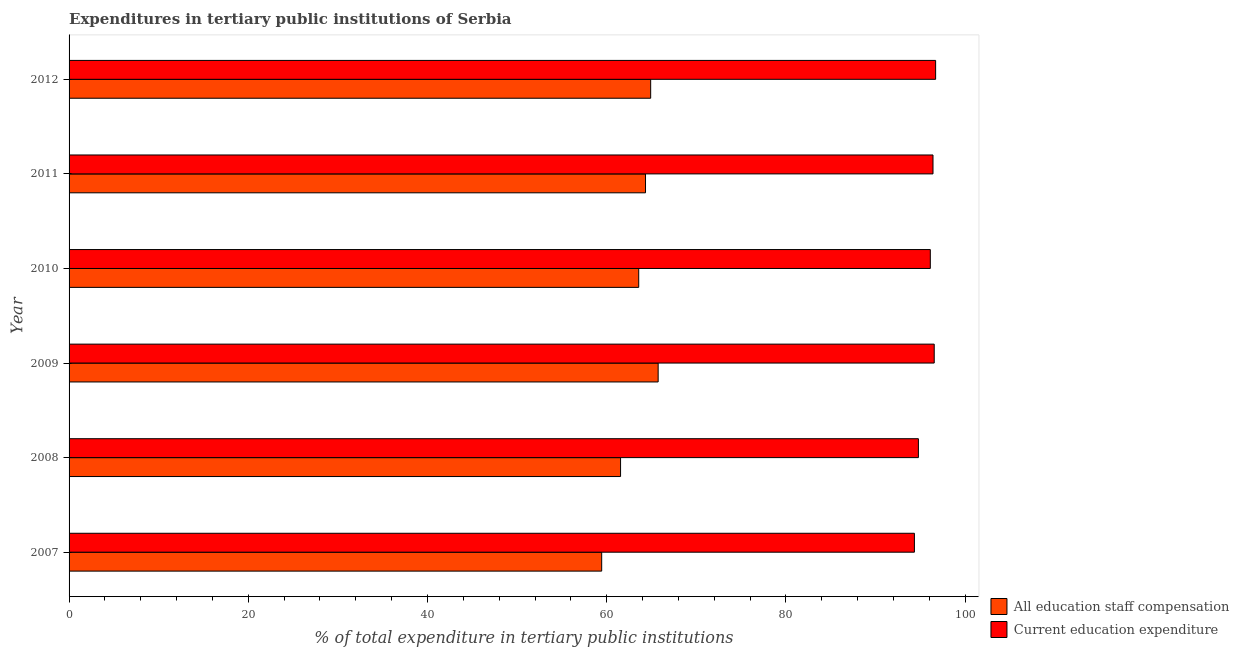How many groups of bars are there?
Make the answer very short. 6. Are the number of bars on each tick of the Y-axis equal?
Offer a terse response. Yes. In how many cases, is the number of bars for a given year not equal to the number of legend labels?
Give a very brief answer. 0. What is the expenditure in staff compensation in 2011?
Make the answer very short. 64.33. Across all years, what is the maximum expenditure in education?
Your answer should be compact. 96.71. Across all years, what is the minimum expenditure in staff compensation?
Ensure brevity in your answer.  59.44. In which year was the expenditure in staff compensation maximum?
Provide a short and direct response. 2009. What is the total expenditure in staff compensation in the graph?
Offer a terse response. 379.54. What is the difference between the expenditure in education in 2010 and that in 2012?
Give a very brief answer. -0.59. What is the difference between the expenditure in staff compensation in 2011 and the expenditure in education in 2009?
Ensure brevity in your answer.  -32.22. What is the average expenditure in education per year?
Your answer should be compact. 95.82. In the year 2011, what is the difference between the expenditure in staff compensation and expenditure in education?
Offer a very short reply. -32.08. What is the ratio of the expenditure in education in 2007 to that in 2010?
Keep it short and to the point. 0.98. Is the expenditure in education in 2010 less than that in 2011?
Provide a short and direct response. Yes. Is the difference between the expenditure in education in 2008 and 2010 greater than the difference between the expenditure in staff compensation in 2008 and 2010?
Provide a short and direct response. Yes. What is the difference between the highest and the second highest expenditure in staff compensation?
Offer a terse response. 0.83. What is the difference between the highest and the lowest expenditure in education?
Your answer should be compact. 2.37. Is the sum of the expenditure in staff compensation in 2007 and 2011 greater than the maximum expenditure in education across all years?
Your response must be concise. Yes. What does the 1st bar from the top in 2007 represents?
Ensure brevity in your answer.  Current education expenditure. What does the 2nd bar from the bottom in 2008 represents?
Offer a very short reply. Current education expenditure. How many bars are there?
Ensure brevity in your answer.  12. How many years are there in the graph?
Your answer should be compact. 6. Are the values on the major ticks of X-axis written in scientific E-notation?
Offer a terse response. No. Does the graph contain grids?
Your answer should be very brief. No. Where does the legend appear in the graph?
Offer a very short reply. Bottom right. How many legend labels are there?
Give a very brief answer. 2. How are the legend labels stacked?
Make the answer very short. Vertical. What is the title of the graph?
Make the answer very short. Expenditures in tertiary public institutions of Serbia. What is the label or title of the X-axis?
Your answer should be compact. % of total expenditure in tertiary public institutions. What is the label or title of the Y-axis?
Provide a short and direct response. Year. What is the % of total expenditure in tertiary public institutions in All education staff compensation in 2007?
Ensure brevity in your answer.  59.44. What is the % of total expenditure in tertiary public institutions of Current education expenditure in 2007?
Ensure brevity in your answer.  94.34. What is the % of total expenditure in tertiary public institutions in All education staff compensation in 2008?
Give a very brief answer. 61.55. What is the % of total expenditure in tertiary public institutions in Current education expenditure in 2008?
Ensure brevity in your answer.  94.79. What is the % of total expenditure in tertiary public institutions of All education staff compensation in 2009?
Your answer should be compact. 65.74. What is the % of total expenditure in tertiary public institutions in Current education expenditure in 2009?
Provide a succinct answer. 96.55. What is the % of total expenditure in tertiary public institutions of All education staff compensation in 2010?
Offer a terse response. 63.57. What is the % of total expenditure in tertiary public institutions in Current education expenditure in 2010?
Make the answer very short. 96.12. What is the % of total expenditure in tertiary public institutions in All education staff compensation in 2011?
Keep it short and to the point. 64.33. What is the % of total expenditure in tertiary public institutions of Current education expenditure in 2011?
Give a very brief answer. 96.42. What is the % of total expenditure in tertiary public institutions of All education staff compensation in 2012?
Provide a succinct answer. 64.91. What is the % of total expenditure in tertiary public institutions of Current education expenditure in 2012?
Offer a terse response. 96.71. Across all years, what is the maximum % of total expenditure in tertiary public institutions in All education staff compensation?
Ensure brevity in your answer.  65.74. Across all years, what is the maximum % of total expenditure in tertiary public institutions of Current education expenditure?
Provide a succinct answer. 96.71. Across all years, what is the minimum % of total expenditure in tertiary public institutions in All education staff compensation?
Offer a very short reply. 59.44. Across all years, what is the minimum % of total expenditure in tertiary public institutions in Current education expenditure?
Your answer should be compact. 94.34. What is the total % of total expenditure in tertiary public institutions in All education staff compensation in the graph?
Provide a succinct answer. 379.54. What is the total % of total expenditure in tertiary public institutions of Current education expenditure in the graph?
Your answer should be very brief. 574.92. What is the difference between the % of total expenditure in tertiary public institutions in All education staff compensation in 2007 and that in 2008?
Give a very brief answer. -2.11. What is the difference between the % of total expenditure in tertiary public institutions in Current education expenditure in 2007 and that in 2008?
Provide a succinct answer. -0.45. What is the difference between the % of total expenditure in tertiary public institutions in All education staff compensation in 2007 and that in 2009?
Your answer should be compact. -6.3. What is the difference between the % of total expenditure in tertiary public institutions in Current education expenditure in 2007 and that in 2009?
Offer a terse response. -2.21. What is the difference between the % of total expenditure in tertiary public institutions in All education staff compensation in 2007 and that in 2010?
Your answer should be compact. -4.13. What is the difference between the % of total expenditure in tertiary public institutions in Current education expenditure in 2007 and that in 2010?
Your response must be concise. -1.77. What is the difference between the % of total expenditure in tertiary public institutions in All education staff compensation in 2007 and that in 2011?
Your answer should be very brief. -4.89. What is the difference between the % of total expenditure in tertiary public institutions in Current education expenditure in 2007 and that in 2011?
Keep it short and to the point. -2.07. What is the difference between the % of total expenditure in tertiary public institutions of All education staff compensation in 2007 and that in 2012?
Make the answer very short. -5.47. What is the difference between the % of total expenditure in tertiary public institutions of Current education expenditure in 2007 and that in 2012?
Your answer should be very brief. -2.37. What is the difference between the % of total expenditure in tertiary public institutions of All education staff compensation in 2008 and that in 2009?
Provide a short and direct response. -4.19. What is the difference between the % of total expenditure in tertiary public institutions of Current education expenditure in 2008 and that in 2009?
Your answer should be compact. -1.77. What is the difference between the % of total expenditure in tertiary public institutions in All education staff compensation in 2008 and that in 2010?
Provide a short and direct response. -2.03. What is the difference between the % of total expenditure in tertiary public institutions of Current education expenditure in 2008 and that in 2010?
Make the answer very short. -1.33. What is the difference between the % of total expenditure in tertiary public institutions in All education staff compensation in 2008 and that in 2011?
Provide a short and direct response. -2.79. What is the difference between the % of total expenditure in tertiary public institutions of Current education expenditure in 2008 and that in 2011?
Offer a terse response. -1.63. What is the difference between the % of total expenditure in tertiary public institutions in All education staff compensation in 2008 and that in 2012?
Your answer should be very brief. -3.36. What is the difference between the % of total expenditure in tertiary public institutions of Current education expenditure in 2008 and that in 2012?
Provide a succinct answer. -1.92. What is the difference between the % of total expenditure in tertiary public institutions of All education staff compensation in 2009 and that in 2010?
Your response must be concise. 2.17. What is the difference between the % of total expenditure in tertiary public institutions in Current education expenditure in 2009 and that in 2010?
Your answer should be very brief. 0.44. What is the difference between the % of total expenditure in tertiary public institutions in All education staff compensation in 2009 and that in 2011?
Offer a terse response. 1.41. What is the difference between the % of total expenditure in tertiary public institutions of Current education expenditure in 2009 and that in 2011?
Offer a very short reply. 0.14. What is the difference between the % of total expenditure in tertiary public institutions of All education staff compensation in 2009 and that in 2012?
Keep it short and to the point. 0.83. What is the difference between the % of total expenditure in tertiary public institutions of Current education expenditure in 2009 and that in 2012?
Make the answer very short. -0.16. What is the difference between the % of total expenditure in tertiary public institutions of All education staff compensation in 2010 and that in 2011?
Offer a terse response. -0.76. What is the difference between the % of total expenditure in tertiary public institutions in Current education expenditure in 2010 and that in 2011?
Provide a short and direct response. -0.3. What is the difference between the % of total expenditure in tertiary public institutions of All education staff compensation in 2010 and that in 2012?
Provide a short and direct response. -1.33. What is the difference between the % of total expenditure in tertiary public institutions of Current education expenditure in 2010 and that in 2012?
Give a very brief answer. -0.59. What is the difference between the % of total expenditure in tertiary public institutions of All education staff compensation in 2011 and that in 2012?
Make the answer very short. -0.57. What is the difference between the % of total expenditure in tertiary public institutions in Current education expenditure in 2011 and that in 2012?
Make the answer very short. -0.29. What is the difference between the % of total expenditure in tertiary public institutions of All education staff compensation in 2007 and the % of total expenditure in tertiary public institutions of Current education expenditure in 2008?
Your response must be concise. -35.35. What is the difference between the % of total expenditure in tertiary public institutions of All education staff compensation in 2007 and the % of total expenditure in tertiary public institutions of Current education expenditure in 2009?
Provide a short and direct response. -37.11. What is the difference between the % of total expenditure in tertiary public institutions of All education staff compensation in 2007 and the % of total expenditure in tertiary public institutions of Current education expenditure in 2010?
Keep it short and to the point. -36.68. What is the difference between the % of total expenditure in tertiary public institutions in All education staff compensation in 2007 and the % of total expenditure in tertiary public institutions in Current education expenditure in 2011?
Offer a very short reply. -36.97. What is the difference between the % of total expenditure in tertiary public institutions in All education staff compensation in 2007 and the % of total expenditure in tertiary public institutions in Current education expenditure in 2012?
Offer a terse response. -37.27. What is the difference between the % of total expenditure in tertiary public institutions in All education staff compensation in 2008 and the % of total expenditure in tertiary public institutions in Current education expenditure in 2009?
Your answer should be compact. -35.01. What is the difference between the % of total expenditure in tertiary public institutions of All education staff compensation in 2008 and the % of total expenditure in tertiary public institutions of Current education expenditure in 2010?
Ensure brevity in your answer.  -34.57. What is the difference between the % of total expenditure in tertiary public institutions in All education staff compensation in 2008 and the % of total expenditure in tertiary public institutions in Current education expenditure in 2011?
Provide a succinct answer. -34.87. What is the difference between the % of total expenditure in tertiary public institutions of All education staff compensation in 2008 and the % of total expenditure in tertiary public institutions of Current education expenditure in 2012?
Your answer should be very brief. -35.16. What is the difference between the % of total expenditure in tertiary public institutions of All education staff compensation in 2009 and the % of total expenditure in tertiary public institutions of Current education expenditure in 2010?
Offer a very short reply. -30.37. What is the difference between the % of total expenditure in tertiary public institutions in All education staff compensation in 2009 and the % of total expenditure in tertiary public institutions in Current education expenditure in 2011?
Your answer should be very brief. -30.67. What is the difference between the % of total expenditure in tertiary public institutions of All education staff compensation in 2009 and the % of total expenditure in tertiary public institutions of Current education expenditure in 2012?
Your answer should be compact. -30.97. What is the difference between the % of total expenditure in tertiary public institutions of All education staff compensation in 2010 and the % of total expenditure in tertiary public institutions of Current education expenditure in 2011?
Provide a short and direct response. -32.84. What is the difference between the % of total expenditure in tertiary public institutions in All education staff compensation in 2010 and the % of total expenditure in tertiary public institutions in Current education expenditure in 2012?
Your answer should be compact. -33.13. What is the difference between the % of total expenditure in tertiary public institutions in All education staff compensation in 2011 and the % of total expenditure in tertiary public institutions in Current education expenditure in 2012?
Offer a terse response. -32.38. What is the average % of total expenditure in tertiary public institutions in All education staff compensation per year?
Your response must be concise. 63.26. What is the average % of total expenditure in tertiary public institutions in Current education expenditure per year?
Provide a short and direct response. 95.82. In the year 2007, what is the difference between the % of total expenditure in tertiary public institutions in All education staff compensation and % of total expenditure in tertiary public institutions in Current education expenditure?
Provide a short and direct response. -34.9. In the year 2008, what is the difference between the % of total expenditure in tertiary public institutions of All education staff compensation and % of total expenditure in tertiary public institutions of Current education expenditure?
Ensure brevity in your answer.  -33.24. In the year 2009, what is the difference between the % of total expenditure in tertiary public institutions in All education staff compensation and % of total expenditure in tertiary public institutions in Current education expenditure?
Keep it short and to the point. -30.81. In the year 2010, what is the difference between the % of total expenditure in tertiary public institutions of All education staff compensation and % of total expenditure in tertiary public institutions of Current education expenditure?
Your answer should be very brief. -32.54. In the year 2011, what is the difference between the % of total expenditure in tertiary public institutions of All education staff compensation and % of total expenditure in tertiary public institutions of Current education expenditure?
Offer a very short reply. -32.08. In the year 2012, what is the difference between the % of total expenditure in tertiary public institutions of All education staff compensation and % of total expenditure in tertiary public institutions of Current education expenditure?
Offer a very short reply. -31.8. What is the ratio of the % of total expenditure in tertiary public institutions in All education staff compensation in 2007 to that in 2008?
Your answer should be very brief. 0.97. What is the ratio of the % of total expenditure in tertiary public institutions in All education staff compensation in 2007 to that in 2009?
Provide a succinct answer. 0.9. What is the ratio of the % of total expenditure in tertiary public institutions of Current education expenditure in 2007 to that in 2009?
Make the answer very short. 0.98. What is the ratio of the % of total expenditure in tertiary public institutions in All education staff compensation in 2007 to that in 2010?
Offer a very short reply. 0.94. What is the ratio of the % of total expenditure in tertiary public institutions in Current education expenditure in 2007 to that in 2010?
Offer a very short reply. 0.98. What is the ratio of the % of total expenditure in tertiary public institutions of All education staff compensation in 2007 to that in 2011?
Ensure brevity in your answer.  0.92. What is the ratio of the % of total expenditure in tertiary public institutions in Current education expenditure in 2007 to that in 2011?
Your answer should be very brief. 0.98. What is the ratio of the % of total expenditure in tertiary public institutions in All education staff compensation in 2007 to that in 2012?
Provide a succinct answer. 0.92. What is the ratio of the % of total expenditure in tertiary public institutions of Current education expenditure in 2007 to that in 2012?
Your answer should be very brief. 0.98. What is the ratio of the % of total expenditure in tertiary public institutions of All education staff compensation in 2008 to that in 2009?
Your answer should be very brief. 0.94. What is the ratio of the % of total expenditure in tertiary public institutions of Current education expenditure in 2008 to that in 2009?
Make the answer very short. 0.98. What is the ratio of the % of total expenditure in tertiary public institutions of All education staff compensation in 2008 to that in 2010?
Provide a succinct answer. 0.97. What is the ratio of the % of total expenditure in tertiary public institutions of Current education expenditure in 2008 to that in 2010?
Ensure brevity in your answer.  0.99. What is the ratio of the % of total expenditure in tertiary public institutions in All education staff compensation in 2008 to that in 2011?
Give a very brief answer. 0.96. What is the ratio of the % of total expenditure in tertiary public institutions in Current education expenditure in 2008 to that in 2011?
Your response must be concise. 0.98. What is the ratio of the % of total expenditure in tertiary public institutions of All education staff compensation in 2008 to that in 2012?
Provide a short and direct response. 0.95. What is the ratio of the % of total expenditure in tertiary public institutions in Current education expenditure in 2008 to that in 2012?
Provide a succinct answer. 0.98. What is the ratio of the % of total expenditure in tertiary public institutions of All education staff compensation in 2009 to that in 2010?
Keep it short and to the point. 1.03. What is the ratio of the % of total expenditure in tertiary public institutions in All education staff compensation in 2009 to that in 2011?
Your answer should be compact. 1.02. What is the ratio of the % of total expenditure in tertiary public institutions in Current education expenditure in 2009 to that in 2011?
Provide a short and direct response. 1. What is the ratio of the % of total expenditure in tertiary public institutions of All education staff compensation in 2009 to that in 2012?
Provide a short and direct response. 1.01. What is the ratio of the % of total expenditure in tertiary public institutions in Current education expenditure in 2009 to that in 2012?
Offer a very short reply. 1. What is the ratio of the % of total expenditure in tertiary public institutions of All education staff compensation in 2010 to that in 2011?
Keep it short and to the point. 0.99. What is the ratio of the % of total expenditure in tertiary public institutions of All education staff compensation in 2010 to that in 2012?
Your answer should be very brief. 0.98. What is the ratio of the % of total expenditure in tertiary public institutions in Current education expenditure in 2010 to that in 2012?
Make the answer very short. 0.99. What is the ratio of the % of total expenditure in tertiary public institutions of All education staff compensation in 2011 to that in 2012?
Provide a short and direct response. 0.99. What is the difference between the highest and the second highest % of total expenditure in tertiary public institutions of All education staff compensation?
Your answer should be compact. 0.83. What is the difference between the highest and the second highest % of total expenditure in tertiary public institutions of Current education expenditure?
Provide a succinct answer. 0.16. What is the difference between the highest and the lowest % of total expenditure in tertiary public institutions of All education staff compensation?
Ensure brevity in your answer.  6.3. What is the difference between the highest and the lowest % of total expenditure in tertiary public institutions in Current education expenditure?
Your answer should be compact. 2.37. 